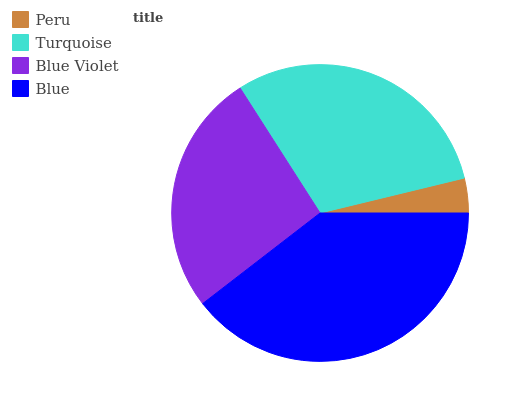Is Peru the minimum?
Answer yes or no. Yes. Is Blue the maximum?
Answer yes or no. Yes. Is Turquoise the minimum?
Answer yes or no. No. Is Turquoise the maximum?
Answer yes or no. No. Is Turquoise greater than Peru?
Answer yes or no. Yes. Is Peru less than Turquoise?
Answer yes or no. Yes. Is Peru greater than Turquoise?
Answer yes or no. No. Is Turquoise less than Peru?
Answer yes or no. No. Is Turquoise the high median?
Answer yes or no. Yes. Is Blue Violet the low median?
Answer yes or no. Yes. Is Blue Violet the high median?
Answer yes or no. No. Is Peru the low median?
Answer yes or no. No. 